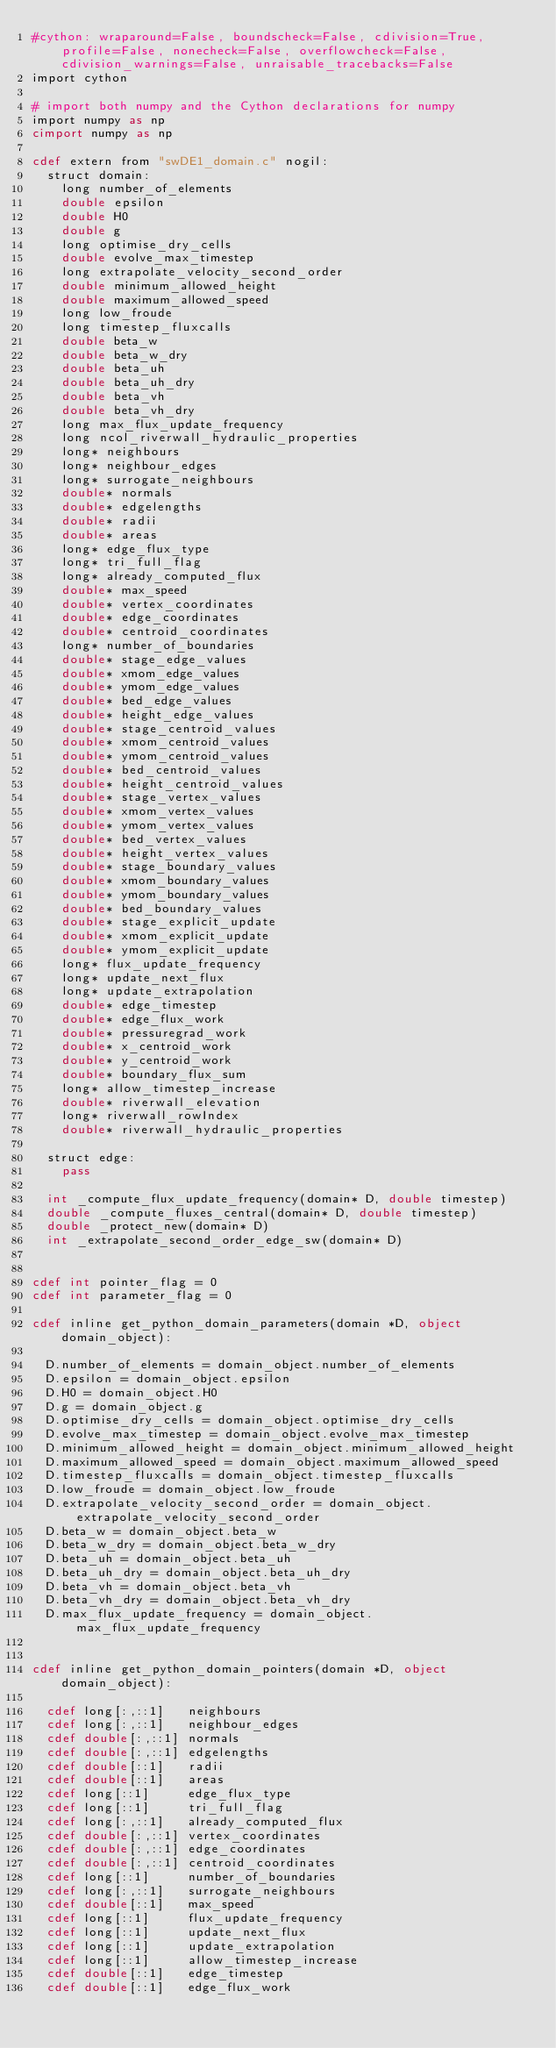Convert code to text. <code><loc_0><loc_0><loc_500><loc_500><_Cython_>#cython: wraparound=False, boundscheck=False, cdivision=True, profile=False, nonecheck=False, overflowcheck=False, cdivision_warnings=False, unraisable_tracebacks=False
import cython

# import both numpy and the Cython declarations for numpy
import numpy as np
cimport numpy as np

cdef extern from "swDE1_domain.c" nogil:
	struct domain:
		long number_of_elements
		double epsilon
		double H0
		double g
		long optimise_dry_cells
		double evolve_max_timestep
		long extrapolate_velocity_second_order
		double minimum_allowed_height
		double maximum_allowed_speed
		long low_froude
		long timestep_fluxcalls
		double beta_w
		double beta_w_dry
		double beta_uh
		double beta_uh_dry
		double beta_vh
		double beta_vh_dry
		long max_flux_update_frequency
		long ncol_riverwall_hydraulic_properties
		long* neighbours
		long* neighbour_edges
		long* surrogate_neighbours
		double* normals
		double* edgelengths
		double* radii
		double* areas
		long* edge_flux_type
		long* tri_full_flag
		long* already_computed_flux
		double* max_speed
		double* vertex_coordinates
		double* edge_coordinates
		double* centroid_coordinates
		long* number_of_boundaries
		double* stage_edge_values
		double* xmom_edge_values
		double* ymom_edge_values
		double* bed_edge_values
		double* height_edge_values
		double* stage_centroid_values
		double* xmom_centroid_values
		double* ymom_centroid_values
		double* bed_centroid_values
		double* height_centroid_values
		double* stage_vertex_values
		double* xmom_vertex_values
		double* ymom_vertex_values
		double* bed_vertex_values
		double* height_vertex_values
		double* stage_boundary_values
		double* xmom_boundary_values
		double* ymom_boundary_values
		double* bed_boundary_values
		double* stage_explicit_update
		double* xmom_explicit_update
		double* ymom_explicit_update
		long* flux_update_frequency
		long* update_next_flux
		long* update_extrapolation
		double* edge_timestep
		double* edge_flux_work
		double* pressuregrad_work
		double* x_centroid_work
		double* y_centroid_work
		double* boundary_flux_sum
		long* allow_timestep_increase
		double* riverwall_elevation
		long* riverwall_rowIndex
		double* riverwall_hydraulic_properties

	struct edge:
		pass

	int _compute_flux_update_frequency(domain* D, double timestep)
	double _compute_fluxes_central(domain* D, double timestep)
	double _protect_new(domain* D)
	int _extrapolate_second_order_edge_sw(domain* D)


cdef int pointer_flag = 0
cdef int parameter_flag = 0

cdef inline get_python_domain_parameters(domain *D, object domain_object):

	D.number_of_elements = domain_object.number_of_elements
	D.epsilon = domain_object.epsilon
	D.H0 = domain_object.H0
	D.g = domain_object.g
	D.optimise_dry_cells = domain_object.optimise_dry_cells
	D.evolve_max_timestep = domain_object.evolve_max_timestep
	D.minimum_allowed_height = domain_object.minimum_allowed_height
	D.maximum_allowed_speed = domain_object.maximum_allowed_speed
	D.timestep_fluxcalls = domain_object.timestep_fluxcalls
	D.low_froude = domain_object.low_froude
	D.extrapolate_velocity_second_order = domain_object.extrapolate_velocity_second_order
	D.beta_w = domain_object.beta_w
	D.beta_w_dry = domain_object.beta_w_dry
	D.beta_uh = domain_object.beta_uh
	D.beta_uh_dry = domain_object.beta_uh_dry
	D.beta_vh = domain_object.beta_vh
	D.beta_vh_dry = domain_object.beta_vh_dry
	D.max_flux_update_frequency = domain_object.max_flux_update_frequency
		

cdef inline get_python_domain_pointers(domain *D, object domain_object):

	cdef long[:,::1]   neighbours
	cdef long[:,::1]   neighbour_edges
	cdef double[:,::1] normals
	cdef double[:,::1] edgelengths
	cdef double[::1]   radii
	cdef double[::1]   areas
	cdef long[::1]     edge_flux_type
	cdef long[::1]     tri_full_flag
	cdef long[:,::1]   already_computed_flux
	cdef double[:,::1] vertex_coordinates
	cdef double[:,::1] edge_coordinates
	cdef double[:,::1] centroid_coordinates
	cdef long[::1]     number_of_boundaries
	cdef long[:,::1]   surrogate_neighbours
	cdef double[::1]   max_speed
	cdef long[::1]     flux_update_frequency
	cdef long[::1]     update_next_flux
	cdef long[::1]     update_extrapolation
	cdef long[::1]     allow_timestep_increase
	cdef double[::1]   edge_timestep
	cdef double[::1]   edge_flux_work</code> 